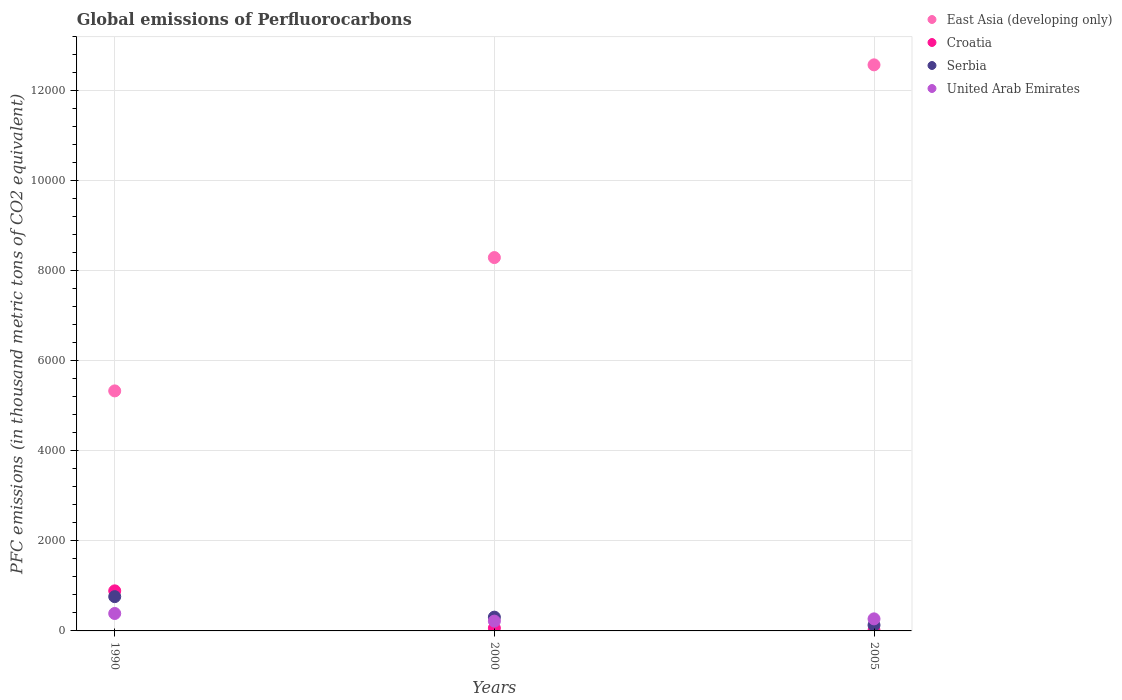How many different coloured dotlines are there?
Make the answer very short. 4. Is the number of dotlines equal to the number of legend labels?
Your response must be concise. Yes. What is the global emissions of Perfluorocarbons in Serbia in 1990?
Your answer should be compact. 761.9. Across all years, what is the maximum global emissions of Perfluorocarbons in United Arab Emirates?
Provide a succinct answer. 387.3. Across all years, what is the minimum global emissions of Perfluorocarbons in Serbia?
Give a very brief answer. 129. In which year was the global emissions of Perfluorocarbons in Serbia maximum?
Your answer should be compact. 1990. What is the total global emissions of Perfluorocarbons in United Arab Emirates in the graph?
Provide a succinct answer. 873.2. What is the difference between the global emissions of Perfluorocarbons in Croatia in 1990 and that in 2005?
Give a very brief answer. 879.5. What is the difference between the global emissions of Perfluorocarbons in East Asia (developing only) in 2000 and the global emissions of Perfluorocarbons in Serbia in 1990?
Your response must be concise. 7533.2. What is the average global emissions of Perfluorocarbons in United Arab Emirates per year?
Provide a succinct answer. 291.07. In the year 2005, what is the difference between the global emissions of Perfluorocarbons in Serbia and global emissions of Perfluorocarbons in East Asia (developing only)?
Provide a succinct answer. -1.24e+04. In how many years, is the global emissions of Perfluorocarbons in United Arab Emirates greater than 4000 thousand metric tons?
Provide a succinct answer. 0. What is the ratio of the global emissions of Perfluorocarbons in Serbia in 1990 to that in 2000?
Make the answer very short. 2.49. Is the global emissions of Perfluorocarbons in Croatia in 1990 less than that in 2000?
Make the answer very short. No. What is the difference between the highest and the second highest global emissions of Perfluorocarbons in Croatia?
Keep it short and to the point. 827.4. What is the difference between the highest and the lowest global emissions of Perfluorocarbons in East Asia (developing only)?
Your answer should be very brief. 7244.02. In how many years, is the global emissions of Perfluorocarbons in Serbia greater than the average global emissions of Perfluorocarbons in Serbia taken over all years?
Give a very brief answer. 1. Is it the case that in every year, the sum of the global emissions of Perfluorocarbons in East Asia (developing only) and global emissions of Perfluorocarbons in Croatia  is greater than the sum of global emissions of Perfluorocarbons in Serbia and global emissions of Perfluorocarbons in United Arab Emirates?
Make the answer very short. No. Is it the case that in every year, the sum of the global emissions of Perfluorocarbons in United Arab Emirates and global emissions of Perfluorocarbons in Serbia  is greater than the global emissions of Perfluorocarbons in Croatia?
Make the answer very short. Yes. Does the global emissions of Perfluorocarbons in Croatia monotonically increase over the years?
Your response must be concise. No. Is the global emissions of Perfluorocarbons in Serbia strictly less than the global emissions of Perfluorocarbons in East Asia (developing only) over the years?
Give a very brief answer. Yes. How many dotlines are there?
Make the answer very short. 4. How many years are there in the graph?
Your answer should be compact. 3. Are the values on the major ticks of Y-axis written in scientific E-notation?
Make the answer very short. No. Does the graph contain grids?
Provide a succinct answer. Yes. How many legend labels are there?
Give a very brief answer. 4. What is the title of the graph?
Provide a succinct answer. Global emissions of Perfluorocarbons. What is the label or title of the X-axis?
Give a very brief answer. Years. What is the label or title of the Y-axis?
Provide a succinct answer. PFC emissions (in thousand metric tons of CO2 equivalent). What is the PFC emissions (in thousand metric tons of CO2 equivalent) of East Asia (developing only) in 1990?
Offer a terse response. 5333. What is the PFC emissions (in thousand metric tons of CO2 equivalent) in Croatia in 1990?
Keep it short and to the point. 890.4. What is the PFC emissions (in thousand metric tons of CO2 equivalent) of Serbia in 1990?
Ensure brevity in your answer.  761.9. What is the PFC emissions (in thousand metric tons of CO2 equivalent) of United Arab Emirates in 1990?
Offer a terse response. 387.3. What is the PFC emissions (in thousand metric tons of CO2 equivalent) of East Asia (developing only) in 2000?
Your response must be concise. 8295.1. What is the PFC emissions (in thousand metric tons of CO2 equivalent) in Serbia in 2000?
Provide a succinct answer. 306.1. What is the PFC emissions (in thousand metric tons of CO2 equivalent) of United Arab Emirates in 2000?
Provide a succinct answer. 218. What is the PFC emissions (in thousand metric tons of CO2 equivalent) in East Asia (developing only) in 2005?
Offer a terse response. 1.26e+04. What is the PFC emissions (in thousand metric tons of CO2 equivalent) in Serbia in 2005?
Make the answer very short. 129. What is the PFC emissions (in thousand metric tons of CO2 equivalent) in United Arab Emirates in 2005?
Provide a succinct answer. 267.9. Across all years, what is the maximum PFC emissions (in thousand metric tons of CO2 equivalent) of East Asia (developing only)?
Offer a terse response. 1.26e+04. Across all years, what is the maximum PFC emissions (in thousand metric tons of CO2 equivalent) of Croatia?
Your answer should be very brief. 890.4. Across all years, what is the maximum PFC emissions (in thousand metric tons of CO2 equivalent) of Serbia?
Your answer should be compact. 761.9. Across all years, what is the maximum PFC emissions (in thousand metric tons of CO2 equivalent) in United Arab Emirates?
Make the answer very short. 387.3. Across all years, what is the minimum PFC emissions (in thousand metric tons of CO2 equivalent) in East Asia (developing only)?
Offer a terse response. 5333. Across all years, what is the minimum PFC emissions (in thousand metric tons of CO2 equivalent) in Serbia?
Your answer should be very brief. 129. Across all years, what is the minimum PFC emissions (in thousand metric tons of CO2 equivalent) in United Arab Emirates?
Provide a short and direct response. 218. What is the total PFC emissions (in thousand metric tons of CO2 equivalent) of East Asia (developing only) in the graph?
Give a very brief answer. 2.62e+04. What is the total PFC emissions (in thousand metric tons of CO2 equivalent) in Croatia in the graph?
Keep it short and to the point. 964.3. What is the total PFC emissions (in thousand metric tons of CO2 equivalent) in Serbia in the graph?
Ensure brevity in your answer.  1197. What is the total PFC emissions (in thousand metric tons of CO2 equivalent) of United Arab Emirates in the graph?
Your answer should be compact. 873.2. What is the difference between the PFC emissions (in thousand metric tons of CO2 equivalent) of East Asia (developing only) in 1990 and that in 2000?
Provide a succinct answer. -2962.1. What is the difference between the PFC emissions (in thousand metric tons of CO2 equivalent) of Croatia in 1990 and that in 2000?
Keep it short and to the point. 827.4. What is the difference between the PFC emissions (in thousand metric tons of CO2 equivalent) of Serbia in 1990 and that in 2000?
Your response must be concise. 455.8. What is the difference between the PFC emissions (in thousand metric tons of CO2 equivalent) in United Arab Emirates in 1990 and that in 2000?
Make the answer very short. 169.3. What is the difference between the PFC emissions (in thousand metric tons of CO2 equivalent) in East Asia (developing only) in 1990 and that in 2005?
Your response must be concise. -7244.02. What is the difference between the PFC emissions (in thousand metric tons of CO2 equivalent) of Croatia in 1990 and that in 2005?
Make the answer very short. 879.5. What is the difference between the PFC emissions (in thousand metric tons of CO2 equivalent) of Serbia in 1990 and that in 2005?
Offer a terse response. 632.9. What is the difference between the PFC emissions (in thousand metric tons of CO2 equivalent) of United Arab Emirates in 1990 and that in 2005?
Your response must be concise. 119.4. What is the difference between the PFC emissions (in thousand metric tons of CO2 equivalent) in East Asia (developing only) in 2000 and that in 2005?
Provide a short and direct response. -4281.92. What is the difference between the PFC emissions (in thousand metric tons of CO2 equivalent) in Croatia in 2000 and that in 2005?
Provide a short and direct response. 52.1. What is the difference between the PFC emissions (in thousand metric tons of CO2 equivalent) in Serbia in 2000 and that in 2005?
Your response must be concise. 177.1. What is the difference between the PFC emissions (in thousand metric tons of CO2 equivalent) in United Arab Emirates in 2000 and that in 2005?
Your response must be concise. -49.9. What is the difference between the PFC emissions (in thousand metric tons of CO2 equivalent) in East Asia (developing only) in 1990 and the PFC emissions (in thousand metric tons of CO2 equivalent) in Croatia in 2000?
Your answer should be compact. 5270. What is the difference between the PFC emissions (in thousand metric tons of CO2 equivalent) in East Asia (developing only) in 1990 and the PFC emissions (in thousand metric tons of CO2 equivalent) in Serbia in 2000?
Provide a succinct answer. 5026.9. What is the difference between the PFC emissions (in thousand metric tons of CO2 equivalent) of East Asia (developing only) in 1990 and the PFC emissions (in thousand metric tons of CO2 equivalent) of United Arab Emirates in 2000?
Your answer should be very brief. 5115. What is the difference between the PFC emissions (in thousand metric tons of CO2 equivalent) of Croatia in 1990 and the PFC emissions (in thousand metric tons of CO2 equivalent) of Serbia in 2000?
Your answer should be compact. 584.3. What is the difference between the PFC emissions (in thousand metric tons of CO2 equivalent) of Croatia in 1990 and the PFC emissions (in thousand metric tons of CO2 equivalent) of United Arab Emirates in 2000?
Offer a very short reply. 672.4. What is the difference between the PFC emissions (in thousand metric tons of CO2 equivalent) of Serbia in 1990 and the PFC emissions (in thousand metric tons of CO2 equivalent) of United Arab Emirates in 2000?
Your answer should be very brief. 543.9. What is the difference between the PFC emissions (in thousand metric tons of CO2 equivalent) in East Asia (developing only) in 1990 and the PFC emissions (in thousand metric tons of CO2 equivalent) in Croatia in 2005?
Your answer should be compact. 5322.1. What is the difference between the PFC emissions (in thousand metric tons of CO2 equivalent) of East Asia (developing only) in 1990 and the PFC emissions (in thousand metric tons of CO2 equivalent) of Serbia in 2005?
Your answer should be compact. 5204. What is the difference between the PFC emissions (in thousand metric tons of CO2 equivalent) in East Asia (developing only) in 1990 and the PFC emissions (in thousand metric tons of CO2 equivalent) in United Arab Emirates in 2005?
Give a very brief answer. 5065.1. What is the difference between the PFC emissions (in thousand metric tons of CO2 equivalent) in Croatia in 1990 and the PFC emissions (in thousand metric tons of CO2 equivalent) in Serbia in 2005?
Your response must be concise. 761.4. What is the difference between the PFC emissions (in thousand metric tons of CO2 equivalent) in Croatia in 1990 and the PFC emissions (in thousand metric tons of CO2 equivalent) in United Arab Emirates in 2005?
Make the answer very short. 622.5. What is the difference between the PFC emissions (in thousand metric tons of CO2 equivalent) of Serbia in 1990 and the PFC emissions (in thousand metric tons of CO2 equivalent) of United Arab Emirates in 2005?
Give a very brief answer. 494. What is the difference between the PFC emissions (in thousand metric tons of CO2 equivalent) in East Asia (developing only) in 2000 and the PFC emissions (in thousand metric tons of CO2 equivalent) in Croatia in 2005?
Provide a succinct answer. 8284.2. What is the difference between the PFC emissions (in thousand metric tons of CO2 equivalent) in East Asia (developing only) in 2000 and the PFC emissions (in thousand metric tons of CO2 equivalent) in Serbia in 2005?
Keep it short and to the point. 8166.1. What is the difference between the PFC emissions (in thousand metric tons of CO2 equivalent) of East Asia (developing only) in 2000 and the PFC emissions (in thousand metric tons of CO2 equivalent) of United Arab Emirates in 2005?
Offer a very short reply. 8027.2. What is the difference between the PFC emissions (in thousand metric tons of CO2 equivalent) of Croatia in 2000 and the PFC emissions (in thousand metric tons of CO2 equivalent) of Serbia in 2005?
Keep it short and to the point. -66. What is the difference between the PFC emissions (in thousand metric tons of CO2 equivalent) in Croatia in 2000 and the PFC emissions (in thousand metric tons of CO2 equivalent) in United Arab Emirates in 2005?
Ensure brevity in your answer.  -204.9. What is the difference between the PFC emissions (in thousand metric tons of CO2 equivalent) in Serbia in 2000 and the PFC emissions (in thousand metric tons of CO2 equivalent) in United Arab Emirates in 2005?
Offer a terse response. 38.2. What is the average PFC emissions (in thousand metric tons of CO2 equivalent) of East Asia (developing only) per year?
Offer a very short reply. 8735.04. What is the average PFC emissions (in thousand metric tons of CO2 equivalent) of Croatia per year?
Provide a succinct answer. 321.43. What is the average PFC emissions (in thousand metric tons of CO2 equivalent) of Serbia per year?
Your answer should be very brief. 399. What is the average PFC emissions (in thousand metric tons of CO2 equivalent) of United Arab Emirates per year?
Give a very brief answer. 291.07. In the year 1990, what is the difference between the PFC emissions (in thousand metric tons of CO2 equivalent) of East Asia (developing only) and PFC emissions (in thousand metric tons of CO2 equivalent) of Croatia?
Your response must be concise. 4442.6. In the year 1990, what is the difference between the PFC emissions (in thousand metric tons of CO2 equivalent) of East Asia (developing only) and PFC emissions (in thousand metric tons of CO2 equivalent) of Serbia?
Make the answer very short. 4571.1. In the year 1990, what is the difference between the PFC emissions (in thousand metric tons of CO2 equivalent) of East Asia (developing only) and PFC emissions (in thousand metric tons of CO2 equivalent) of United Arab Emirates?
Offer a terse response. 4945.7. In the year 1990, what is the difference between the PFC emissions (in thousand metric tons of CO2 equivalent) of Croatia and PFC emissions (in thousand metric tons of CO2 equivalent) of Serbia?
Offer a very short reply. 128.5. In the year 1990, what is the difference between the PFC emissions (in thousand metric tons of CO2 equivalent) of Croatia and PFC emissions (in thousand metric tons of CO2 equivalent) of United Arab Emirates?
Ensure brevity in your answer.  503.1. In the year 1990, what is the difference between the PFC emissions (in thousand metric tons of CO2 equivalent) of Serbia and PFC emissions (in thousand metric tons of CO2 equivalent) of United Arab Emirates?
Your response must be concise. 374.6. In the year 2000, what is the difference between the PFC emissions (in thousand metric tons of CO2 equivalent) in East Asia (developing only) and PFC emissions (in thousand metric tons of CO2 equivalent) in Croatia?
Your answer should be very brief. 8232.1. In the year 2000, what is the difference between the PFC emissions (in thousand metric tons of CO2 equivalent) in East Asia (developing only) and PFC emissions (in thousand metric tons of CO2 equivalent) in Serbia?
Your answer should be compact. 7989. In the year 2000, what is the difference between the PFC emissions (in thousand metric tons of CO2 equivalent) in East Asia (developing only) and PFC emissions (in thousand metric tons of CO2 equivalent) in United Arab Emirates?
Give a very brief answer. 8077.1. In the year 2000, what is the difference between the PFC emissions (in thousand metric tons of CO2 equivalent) in Croatia and PFC emissions (in thousand metric tons of CO2 equivalent) in Serbia?
Your answer should be compact. -243.1. In the year 2000, what is the difference between the PFC emissions (in thousand metric tons of CO2 equivalent) in Croatia and PFC emissions (in thousand metric tons of CO2 equivalent) in United Arab Emirates?
Offer a terse response. -155. In the year 2000, what is the difference between the PFC emissions (in thousand metric tons of CO2 equivalent) in Serbia and PFC emissions (in thousand metric tons of CO2 equivalent) in United Arab Emirates?
Provide a succinct answer. 88.1. In the year 2005, what is the difference between the PFC emissions (in thousand metric tons of CO2 equivalent) in East Asia (developing only) and PFC emissions (in thousand metric tons of CO2 equivalent) in Croatia?
Provide a succinct answer. 1.26e+04. In the year 2005, what is the difference between the PFC emissions (in thousand metric tons of CO2 equivalent) in East Asia (developing only) and PFC emissions (in thousand metric tons of CO2 equivalent) in Serbia?
Provide a short and direct response. 1.24e+04. In the year 2005, what is the difference between the PFC emissions (in thousand metric tons of CO2 equivalent) in East Asia (developing only) and PFC emissions (in thousand metric tons of CO2 equivalent) in United Arab Emirates?
Provide a succinct answer. 1.23e+04. In the year 2005, what is the difference between the PFC emissions (in thousand metric tons of CO2 equivalent) of Croatia and PFC emissions (in thousand metric tons of CO2 equivalent) of Serbia?
Make the answer very short. -118.1. In the year 2005, what is the difference between the PFC emissions (in thousand metric tons of CO2 equivalent) in Croatia and PFC emissions (in thousand metric tons of CO2 equivalent) in United Arab Emirates?
Offer a terse response. -257. In the year 2005, what is the difference between the PFC emissions (in thousand metric tons of CO2 equivalent) in Serbia and PFC emissions (in thousand metric tons of CO2 equivalent) in United Arab Emirates?
Provide a succinct answer. -138.9. What is the ratio of the PFC emissions (in thousand metric tons of CO2 equivalent) in East Asia (developing only) in 1990 to that in 2000?
Offer a terse response. 0.64. What is the ratio of the PFC emissions (in thousand metric tons of CO2 equivalent) in Croatia in 1990 to that in 2000?
Your answer should be very brief. 14.13. What is the ratio of the PFC emissions (in thousand metric tons of CO2 equivalent) in Serbia in 1990 to that in 2000?
Offer a terse response. 2.49. What is the ratio of the PFC emissions (in thousand metric tons of CO2 equivalent) of United Arab Emirates in 1990 to that in 2000?
Provide a short and direct response. 1.78. What is the ratio of the PFC emissions (in thousand metric tons of CO2 equivalent) of East Asia (developing only) in 1990 to that in 2005?
Your response must be concise. 0.42. What is the ratio of the PFC emissions (in thousand metric tons of CO2 equivalent) in Croatia in 1990 to that in 2005?
Your answer should be very brief. 81.69. What is the ratio of the PFC emissions (in thousand metric tons of CO2 equivalent) of Serbia in 1990 to that in 2005?
Keep it short and to the point. 5.91. What is the ratio of the PFC emissions (in thousand metric tons of CO2 equivalent) in United Arab Emirates in 1990 to that in 2005?
Ensure brevity in your answer.  1.45. What is the ratio of the PFC emissions (in thousand metric tons of CO2 equivalent) of East Asia (developing only) in 2000 to that in 2005?
Ensure brevity in your answer.  0.66. What is the ratio of the PFC emissions (in thousand metric tons of CO2 equivalent) in Croatia in 2000 to that in 2005?
Your response must be concise. 5.78. What is the ratio of the PFC emissions (in thousand metric tons of CO2 equivalent) in Serbia in 2000 to that in 2005?
Make the answer very short. 2.37. What is the ratio of the PFC emissions (in thousand metric tons of CO2 equivalent) in United Arab Emirates in 2000 to that in 2005?
Keep it short and to the point. 0.81. What is the difference between the highest and the second highest PFC emissions (in thousand metric tons of CO2 equivalent) in East Asia (developing only)?
Your answer should be compact. 4281.92. What is the difference between the highest and the second highest PFC emissions (in thousand metric tons of CO2 equivalent) of Croatia?
Your response must be concise. 827.4. What is the difference between the highest and the second highest PFC emissions (in thousand metric tons of CO2 equivalent) of Serbia?
Ensure brevity in your answer.  455.8. What is the difference between the highest and the second highest PFC emissions (in thousand metric tons of CO2 equivalent) in United Arab Emirates?
Offer a very short reply. 119.4. What is the difference between the highest and the lowest PFC emissions (in thousand metric tons of CO2 equivalent) in East Asia (developing only)?
Provide a succinct answer. 7244.02. What is the difference between the highest and the lowest PFC emissions (in thousand metric tons of CO2 equivalent) of Croatia?
Offer a very short reply. 879.5. What is the difference between the highest and the lowest PFC emissions (in thousand metric tons of CO2 equivalent) of Serbia?
Make the answer very short. 632.9. What is the difference between the highest and the lowest PFC emissions (in thousand metric tons of CO2 equivalent) of United Arab Emirates?
Your response must be concise. 169.3. 